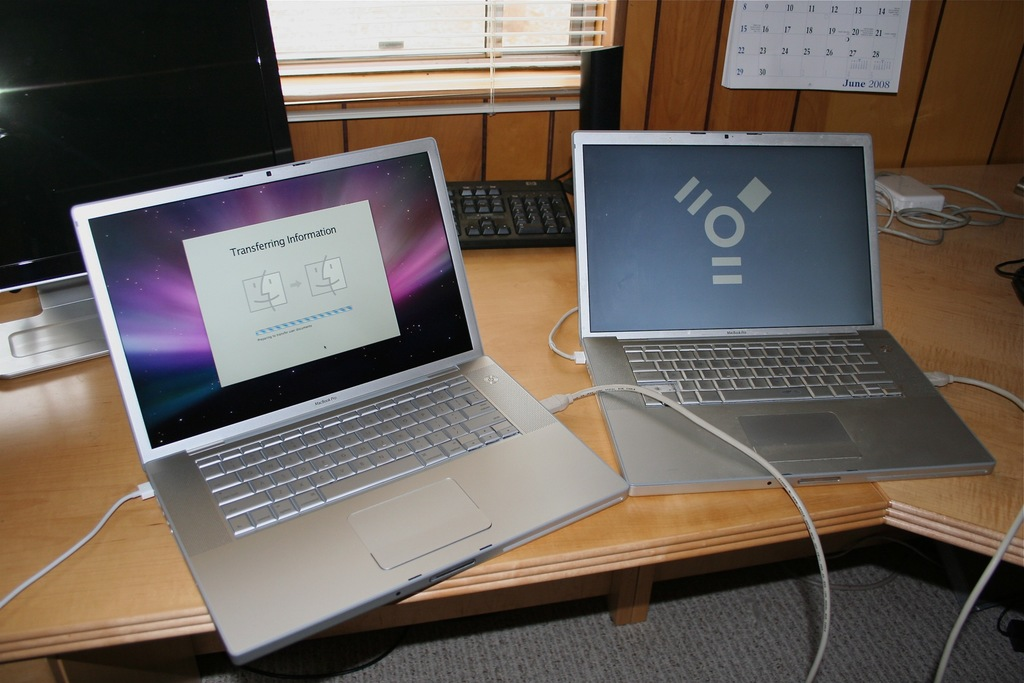Explain the technology used for transferring data between these two laptops. The laptops are likely using a direct cable connection to transfer data. This method could involve network settings adjustment or possibly using Target Disk Mode, which allows one MacBook to be used as an external disk by another. 